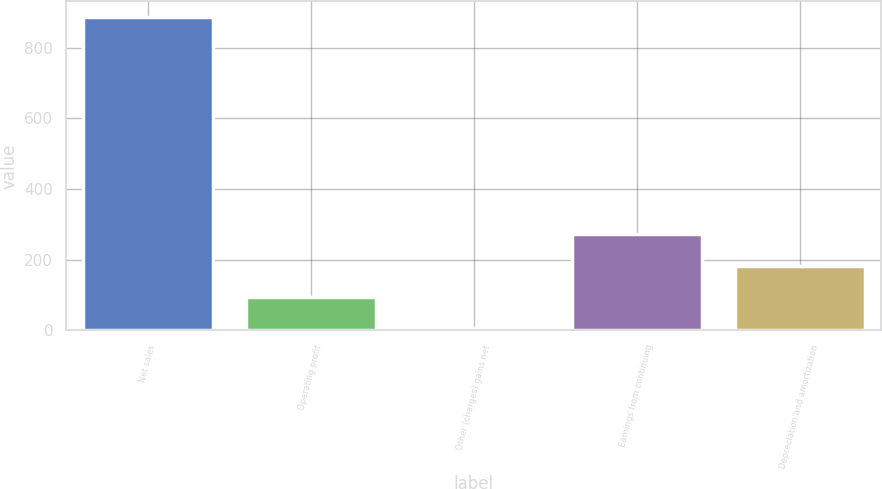Convert chart. <chart><loc_0><loc_0><loc_500><loc_500><bar_chart><fcel>Net sales<fcel>Operating profit<fcel>Other (charges) gains net<fcel>Earnings from continuing<fcel>Depreciation and amortization<nl><fcel>887<fcel>95.9<fcel>8<fcel>271.7<fcel>183.8<nl></chart> 